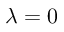Convert formula to latex. <formula><loc_0><loc_0><loc_500><loc_500>\lambda = 0</formula> 